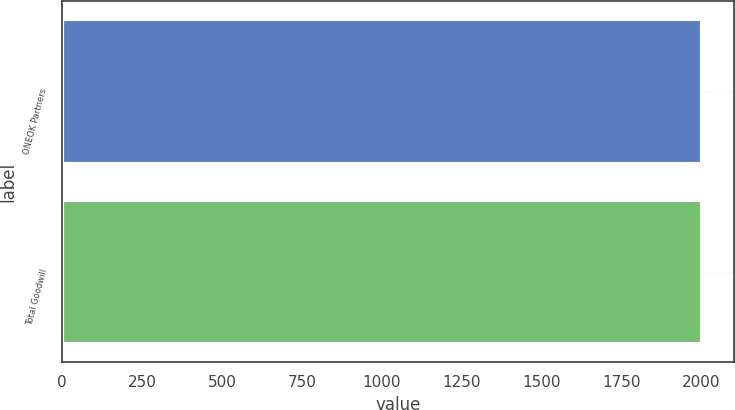<chart> <loc_0><loc_0><loc_500><loc_500><bar_chart><fcel>ONEOK Partners<fcel>Total Goodwill<nl><fcel>2001<fcel>2001.1<nl></chart> 